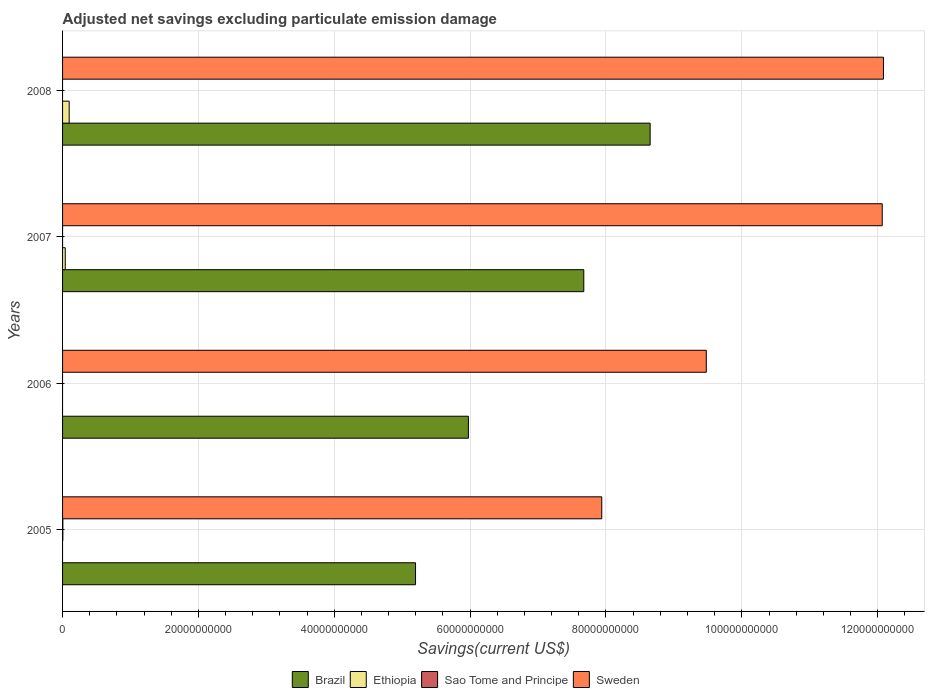How many groups of bars are there?
Offer a very short reply. 4. Are the number of bars on each tick of the Y-axis equal?
Your response must be concise. No. How many bars are there on the 2nd tick from the top?
Keep it short and to the point. 3. What is the adjusted net savings in Ethiopia in 2007?
Your answer should be compact. 3.94e+08. Across all years, what is the maximum adjusted net savings in Sweden?
Give a very brief answer. 1.21e+11. Across all years, what is the minimum adjusted net savings in Sao Tome and Principe?
Offer a terse response. 0. In which year was the adjusted net savings in Brazil maximum?
Ensure brevity in your answer.  2008. What is the total adjusted net savings in Ethiopia in the graph?
Keep it short and to the point. 1.37e+09. What is the difference between the adjusted net savings in Sweden in 2005 and that in 2006?
Your response must be concise. -1.54e+1. What is the difference between the adjusted net savings in Brazil in 2005 and the adjusted net savings in Sao Tome and Principe in 2008?
Provide a succinct answer. 5.20e+1. What is the average adjusted net savings in Ethiopia per year?
Your answer should be very brief. 3.42e+08. In the year 2008, what is the difference between the adjusted net savings in Sweden and adjusted net savings in Ethiopia?
Provide a short and direct response. 1.20e+11. What is the ratio of the adjusted net savings in Ethiopia in 2007 to that in 2008?
Keep it short and to the point. 0.41. Is the adjusted net savings in Sweden in 2006 less than that in 2007?
Your answer should be very brief. Yes. What is the difference between the highest and the lowest adjusted net savings in Sao Tome and Principe?
Your answer should be very brief. 4.16e+07. In how many years, is the adjusted net savings in Brazil greater than the average adjusted net savings in Brazil taken over all years?
Your answer should be compact. 2. Is it the case that in every year, the sum of the adjusted net savings in Sweden and adjusted net savings in Brazil is greater than the adjusted net savings in Sao Tome and Principe?
Provide a succinct answer. Yes. How many bars are there?
Make the answer very short. 11. How many years are there in the graph?
Offer a terse response. 4. What is the difference between two consecutive major ticks on the X-axis?
Provide a short and direct response. 2.00e+1. Does the graph contain grids?
Make the answer very short. Yes. Where does the legend appear in the graph?
Ensure brevity in your answer.  Bottom center. What is the title of the graph?
Your response must be concise. Adjusted net savings excluding particulate emission damage. Does "American Samoa" appear as one of the legend labels in the graph?
Give a very brief answer. No. What is the label or title of the X-axis?
Your response must be concise. Savings(current US$). What is the Savings(current US$) in Brazil in 2005?
Your response must be concise. 5.20e+1. What is the Savings(current US$) in Sao Tome and Principe in 2005?
Provide a succinct answer. 4.16e+07. What is the Savings(current US$) of Sweden in 2005?
Offer a very short reply. 7.94e+1. What is the Savings(current US$) of Brazil in 2006?
Your response must be concise. 5.97e+1. What is the Savings(current US$) in Sweden in 2006?
Your answer should be very brief. 9.48e+1. What is the Savings(current US$) of Brazil in 2007?
Provide a succinct answer. 7.67e+1. What is the Savings(current US$) of Ethiopia in 2007?
Ensure brevity in your answer.  3.94e+08. What is the Savings(current US$) of Sweden in 2007?
Provide a succinct answer. 1.21e+11. What is the Savings(current US$) of Brazil in 2008?
Keep it short and to the point. 8.65e+1. What is the Savings(current US$) in Ethiopia in 2008?
Ensure brevity in your answer.  9.73e+08. What is the Savings(current US$) of Sweden in 2008?
Make the answer very short. 1.21e+11. Across all years, what is the maximum Savings(current US$) in Brazil?
Your response must be concise. 8.65e+1. Across all years, what is the maximum Savings(current US$) of Ethiopia?
Your answer should be very brief. 9.73e+08. Across all years, what is the maximum Savings(current US$) of Sao Tome and Principe?
Offer a very short reply. 4.16e+07. Across all years, what is the maximum Savings(current US$) of Sweden?
Offer a very short reply. 1.21e+11. Across all years, what is the minimum Savings(current US$) in Brazil?
Provide a short and direct response. 5.20e+1. Across all years, what is the minimum Savings(current US$) in Sweden?
Offer a terse response. 7.94e+1. What is the total Savings(current US$) of Brazil in the graph?
Your answer should be compact. 2.75e+11. What is the total Savings(current US$) of Ethiopia in the graph?
Make the answer very short. 1.37e+09. What is the total Savings(current US$) in Sao Tome and Principe in the graph?
Your answer should be compact. 4.16e+07. What is the total Savings(current US$) in Sweden in the graph?
Make the answer very short. 4.16e+11. What is the difference between the Savings(current US$) in Brazil in 2005 and that in 2006?
Your answer should be very brief. -7.78e+09. What is the difference between the Savings(current US$) in Sweden in 2005 and that in 2006?
Your answer should be very brief. -1.54e+1. What is the difference between the Savings(current US$) in Brazil in 2005 and that in 2007?
Offer a terse response. -2.48e+1. What is the difference between the Savings(current US$) in Sweden in 2005 and that in 2007?
Your response must be concise. -4.13e+1. What is the difference between the Savings(current US$) of Brazil in 2005 and that in 2008?
Offer a terse response. -3.45e+1. What is the difference between the Savings(current US$) in Sweden in 2005 and that in 2008?
Offer a very short reply. -4.15e+1. What is the difference between the Savings(current US$) of Brazil in 2006 and that in 2007?
Make the answer very short. -1.70e+1. What is the difference between the Savings(current US$) in Sweden in 2006 and that in 2007?
Offer a terse response. -2.59e+1. What is the difference between the Savings(current US$) in Brazil in 2006 and that in 2008?
Your answer should be compact. -2.68e+1. What is the difference between the Savings(current US$) of Sweden in 2006 and that in 2008?
Provide a succinct answer. -2.61e+1. What is the difference between the Savings(current US$) in Brazil in 2007 and that in 2008?
Provide a succinct answer. -9.77e+09. What is the difference between the Savings(current US$) in Ethiopia in 2007 and that in 2008?
Your response must be concise. -5.78e+08. What is the difference between the Savings(current US$) of Sweden in 2007 and that in 2008?
Offer a terse response. -1.78e+08. What is the difference between the Savings(current US$) of Brazil in 2005 and the Savings(current US$) of Sweden in 2006?
Your answer should be compact. -4.28e+1. What is the difference between the Savings(current US$) of Sao Tome and Principe in 2005 and the Savings(current US$) of Sweden in 2006?
Offer a terse response. -9.47e+1. What is the difference between the Savings(current US$) in Brazil in 2005 and the Savings(current US$) in Ethiopia in 2007?
Provide a succinct answer. 5.16e+1. What is the difference between the Savings(current US$) in Brazil in 2005 and the Savings(current US$) in Sweden in 2007?
Keep it short and to the point. -6.87e+1. What is the difference between the Savings(current US$) in Sao Tome and Principe in 2005 and the Savings(current US$) in Sweden in 2007?
Offer a very short reply. -1.21e+11. What is the difference between the Savings(current US$) in Brazil in 2005 and the Savings(current US$) in Ethiopia in 2008?
Offer a terse response. 5.10e+1. What is the difference between the Savings(current US$) in Brazil in 2005 and the Savings(current US$) in Sweden in 2008?
Offer a terse response. -6.89e+1. What is the difference between the Savings(current US$) of Sao Tome and Principe in 2005 and the Savings(current US$) of Sweden in 2008?
Give a very brief answer. -1.21e+11. What is the difference between the Savings(current US$) in Brazil in 2006 and the Savings(current US$) in Ethiopia in 2007?
Provide a succinct answer. 5.93e+1. What is the difference between the Savings(current US$) of Brazil in 2006 and the Savings(current US$) of Sweden in 2007?
Give a very brief answer. -6.09e+1. What is the difference between the Savings(current US$) in Brazil in 2006 and the Savings(current US$) in Ethiopia in 2008?
Make the answer very short. 5.88e+1. What is the difference between the Savings(current US$) in Brazil in 2006 and the Savings(current US$) in Sweden in 2008?
Offer a terse response. -6.11e+1. What is the difference between the Savings(current US$) of Brazil in 2007 and the Savings(current US$) of Ethiopia in 2008?
Ensure brevity in your answer.  7.58e+1. What is the difference between the Savings(current US$) in Brazil in 2007 and the Savings(current US$) in Sweden in 2008?
Make the answer very short. -4.41e+1. What is the difference between the Savings(current US$) of Ethiopia in 2007 and the Savings(current US$) of Sweden in 2008?
Your answer should be compact. -1.20e+11. What is the average Savings(current US$) of Brazil per year?
Keep it short and to the point. 6.87e+1. What is the average Savings(current US$) of Ethiopia per year?
Offer a terse response. 3.42e+08. What is the average Savings(current US$) of Sao Tome and Principe per year?
Make the answer very short. 1.04e+07. What is the average Savings(current US$) of Sweden per year?
Your response must be concise. 1.04e+11. In the year 2005, what is the difference between the Savings(current US$) in Brazil and Savings(current US$) in Sao Tome and Principe?
Offer a terse response. 5.19e+1. In the year 2005, what is the difference between the Savings(current US$) of Brazil and Savings(current US$) of Sweden?
Offer a terse response. -2.74e+1. In the year 2005, what is the difference between the Savings(current US$) of Sao Tome and Principe and Savings(current US$) of Sweden?
Offer a very short reply. -7.93e+1. In the year 2006, what is the difference between the Savings(current US$) of Brazil and Savings(current US$) of Sweden?
Your response must be concise. -3.50e+1. In the year 2007, what is the difference between the Savings(current US$) in Brazil and Savings(current US$) in Ethiopia?
Keep it short and to the point. 7.63e+1. In the year 2007, what is the difference between the Savings(current US$) in Brazil and Savings(current US$) in Sweden?
Make the answer very short. -4.39e+1. In the year 2007, what is the difference between the Savings(current US$) of Ethiopia and Savings(current US$) of Sweden?
Give a very brief answer. -1.20e+11. In the year 2008, what is the difference between the Savings(current US$) in Brazil and Savings(current US$) in Ethiopia?
Offer a terse response. 8.55e+1. In the year 2008, what is the difference between the Savings(current US$) in Brazil and Savings(current US$) in Sweden?
Your response must be concise. -3.43e+1. In the year 2008, what is the difference between the Savings(current US$) of Ethiopia and Savings(current US$) of Sweden?
Your answer should be compact. -1.20e+11. What is the ratio of the Savings(current US$) of Brazil in 2005 to that in 2006?
Offer a very short reply. 0.87. What is the ratio of the Savings(current US$) in Sweden in 2005 to that in 2006?
Provide a succinct answer. 0.84. What is the ratio of the Savings(current US$) in Brazil in 2005 to that in 2007?
Your answer should be very brief. 0.68. What is the ratio of the Savings(current US$) of Sweden in 2005 to that in 2007?
Your answer should be very brief. 0.66. What is the ratio of the Savings(current US$) in Brazil in 2005 to that in 2008?
Make the answer very short. 0.6. What is the ratio of the Savings(current US$) in Sweden in 2005 to that in 2008?
Your response must be concise. 0.66. What is the ratio of the Savings(current US$) of Brazil in 2006 to that in 2007?
Give a very brief answer. 0.78. What is the ratio of the Savings(current US$) in Sweden in 2006 to that in 2007?
Make the answer very short. 0.79. What is the ratio of the Savings(current US$) in Brazil in 2006 to that in 2008?
Your response must be concise. 0.69. What is the ratio of the Savings(current US$) in Sweden in 2006 to that in 2008?
Offer a very short reply. 0.78. What is the ratio of the Savings(current US$) of Brazil in 2007 to that in 2008?
Your answer should be compact. 0.89. What is the ratio of the Savings(current US$) of Ethiopia in 2007 to that in 2008?
Provide a succinct answer. 0.41. What is the difference between the highest and the second highest Savings(current US$) in Brazil?
Make the answer very short. 9.77e+09. What is the difference between the highest and the second highest Savings(current US$) in Sweden?
Provide a short and direct response. 1.78e+08. What is the difference between the highest and the lowest Savings(current US$) of Brazil?
Offer a very short reply. 3.45e+1. What is the difference between the highest and the lowest Savings(current US$) of Ethiopia?
Offer a terse response. 9.73e+08. What is the difference between the highest and the lowest Savings(current US$) of Sao Tome and Principe?
Offer a terse response. 4.16e+07. What is the difference between the highest and the lowest Savings(current US$) of Sweden?
Ensure brevity in your answer.  4.15e+1. 